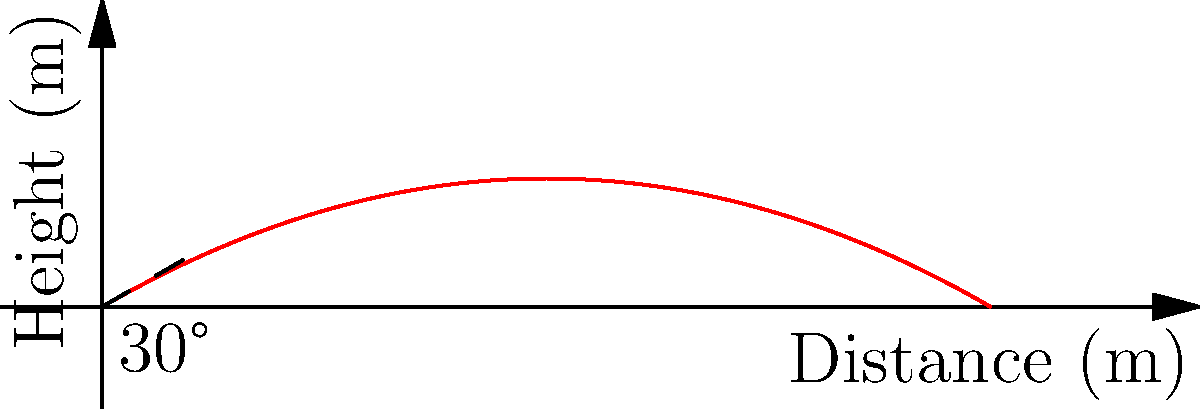In a crucial free kick for Guangzhou FC, the striker needs to determine the optimal angle and initial velocity for the ball to clear a defensive wall and reach the goal. Given that the defensive wall is 1.8 meters tall and 9 meters away from the kicker, what is the minimum initial velocity needed for the ball to clear the wall if kicked at a 30° angle, as shown in the trajectory diagram? To solve this problem, we'll use the equations of projectile motion and follow these steps:

1. The trajectory of the ball is described by:
   $x = v_0 \cos(\theta) t$
   $y = v_0 \sin(\theta) t - \frac{1}{2}gt^2$

   Where $v_0$ is the initial velocity, $\theta$ is the launch angle, $g$ is the acceleration due to gravity (9.8 m/s²), and $t$ is time.

2. We know that the ball needs to clear the wall at $x = 9$ m and $y = 1.8$ m. We can use these values to find the time $t$ when the ball reaches the wall:

   $9 = v_0 \cos(30°) t$
   $t = \frac{9}{v_0 \cos(30°)}$

3. Substitute this time into the equation for $y$:

   $1.8 = v_0 \sin(30°) (\frac{9}{v_0 \cos(30°)}) - \frac{1}{2}g(\frac{9}{v_0 \cos(30°)})^2$

4. Simplify and solve for $v_0$:

   $1.8 = 9 \tan(30°) - \frac{1}{2}g(\frac{9}{v_0 \cos(30°)})^2$
   $1.8 = 5.2 - \frac{405g}{2v_0^2 \cos^2(30°)}$
   $\frac{405g}{2v_0^2 \cos^2(30°)} = 3.4$
   $v_0^2 = \frac{405g}{6.8 \cos^2(30°)}$
   $v_0 = \sqrt{\frac{405 * 9.8}{6.8 * (\frac{\sqrt{3}}{2})^2}} \approx 24.7$ m/s

5. Therefore, the minimum initial velocity needed is approximately 24.7 m/s or 25 m/s when rounded to the nearest whole number.
Answer: 25 m/s 